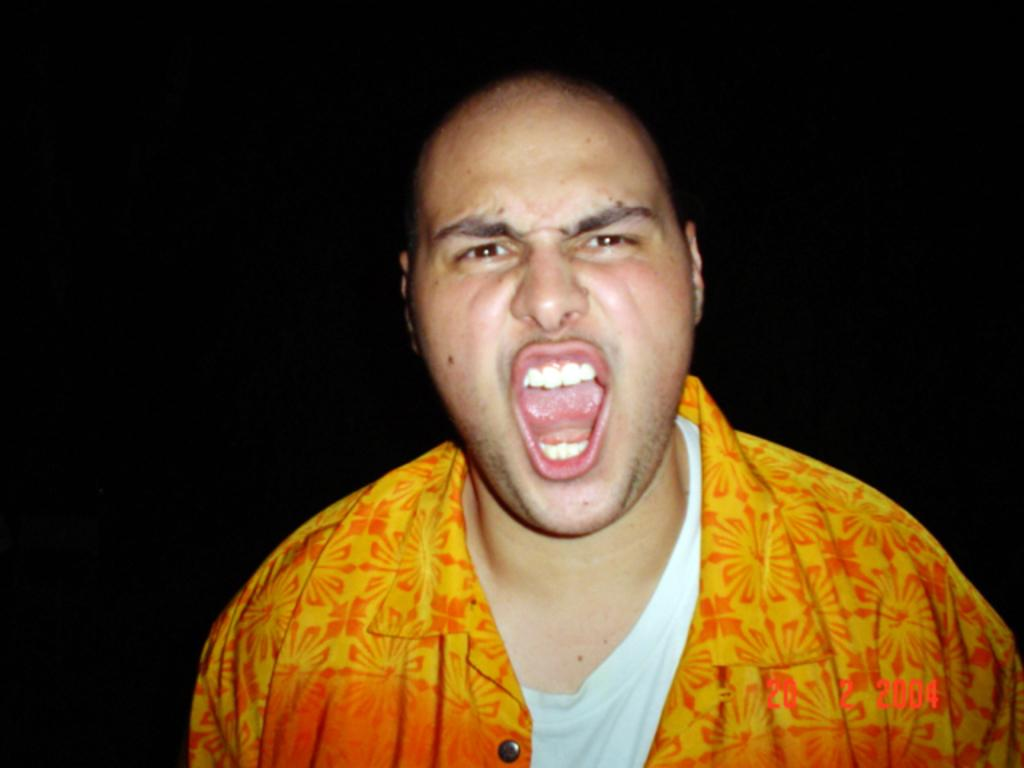Who is the main subject in the image? There is a man in the center of the image. What color is the background of the image? The background of the image is black. Can you tell me the date that is visible in the image? The date is visible in the bottom right corner of the image. What type of offer is the man making at the seashore in the image? There is no seashore present in the image, and the man is not making any offer. 